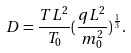<formula> <loc_0><loc_0><loc_500><loc_500>D = \frac { T L ^ { 2 } } { T _ { 0 } } ( \frac { q L ^ { 2 } } { m _ { 0 } ^ { 2 } } ) ^ { \frac { 1 } { 3 } } .</formula> 